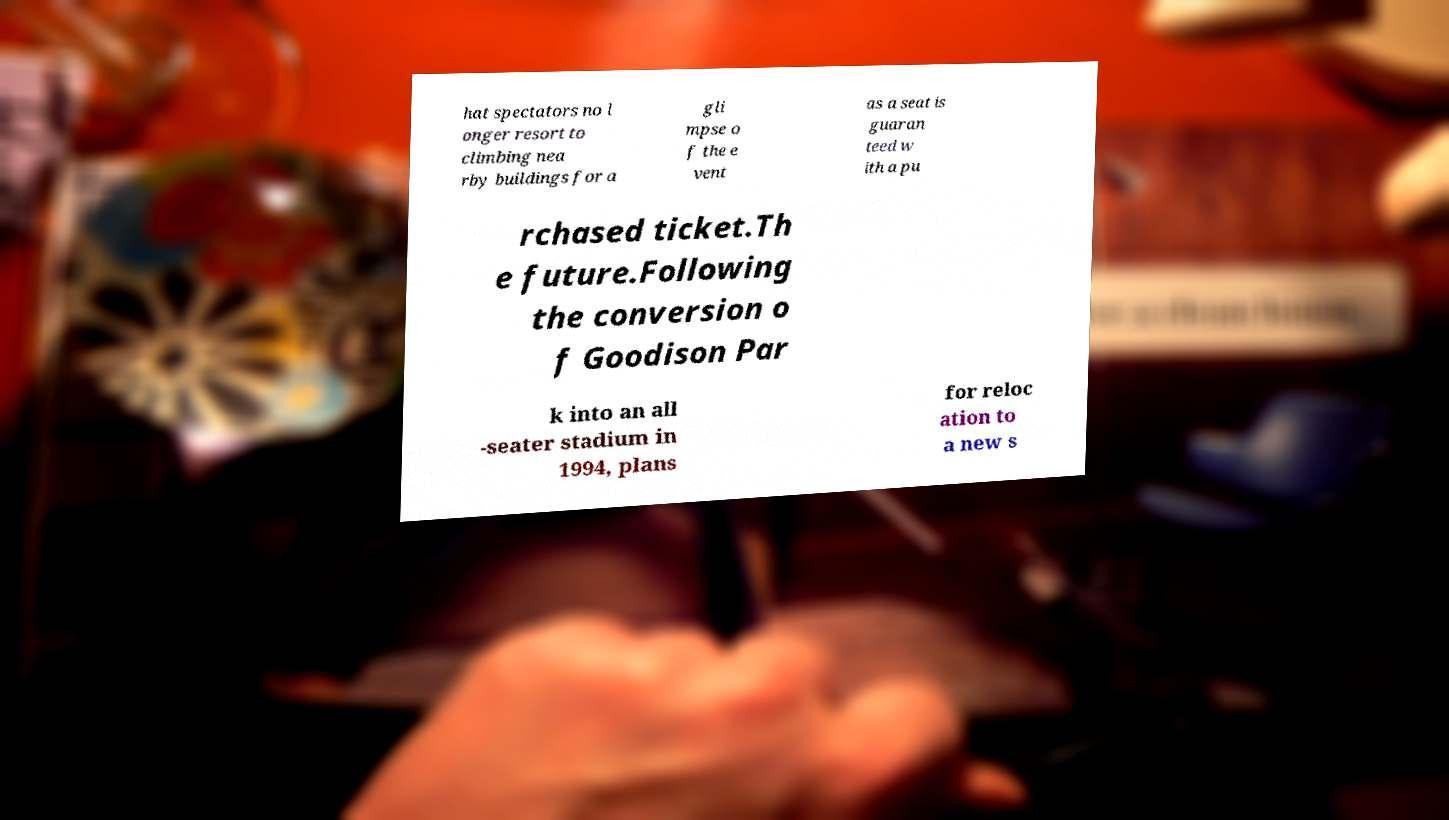I need the written content from this picture converted into text. Can you do that? hat spectators no l onger resort to climbing nea rby buildings for a gli mpse o f the e vent as a seat is guaran teed w ith a pu rchased ticket.Th e future.Following the conversion o f Goodison Par k into an all -seater stadium in 1994, plans for reloc ation to a new s 